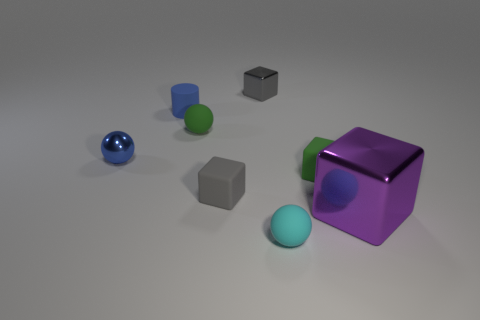Add 2 blocks. How many objects exist? 10 Subtract all balls. How many objects are left? 5 Add 4 small cylinders. How many small cylinders exist? 5 Subtract 1 green spheres. How many objects are left? 7 Subtract all blue cylinders. Subtract all green objects. How many objects are left? 5 Add 5 small green cubes. How many small green cubes are left? 6 